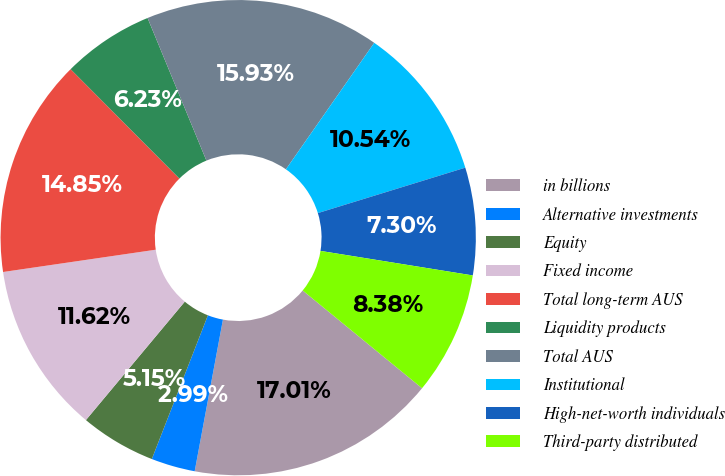<chart> <loc_0><loc_0><loc_500><loc_500><pie_chart><fcel>in billions<fcel>Alternative investments<fcel>Equity<fcel>Fixed income<fcel>Total long-term AUS<fcel>Liquidity products<fcel>Total AUS<fcel>Institutional<fcel>High-net-worth individuals<fcel>Third-party distributed<nl><fcel>17.01%<fcel>2.99%<fcel>5.15%<fcel>11.62%<fcel>14.85%<fcel>6.23%<fcel>15.93%<fcel>10.54%<fcel>7.3%<fcel>8.38%<nl></chart> 